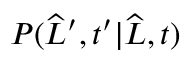<formula> <loc_0><loc_0><loc_500><loc_500>P ( \widehat { L } ^ { \prime } , t ^ { \prime } | \widehat { L } , t )</formula> 